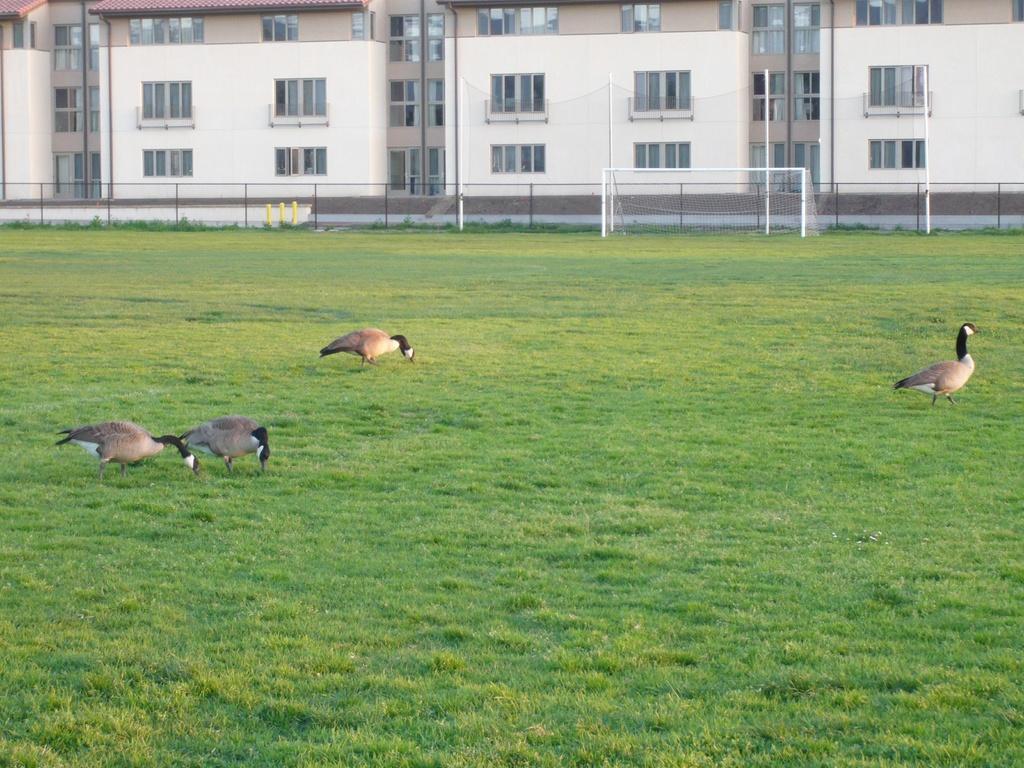Can you describe this image briefly? In front of the image there are ducks. At the bottom of the image there is grass on the surface. In the background of the image there is a volleyball net. There is a metal fence. There are poles and buildings. 